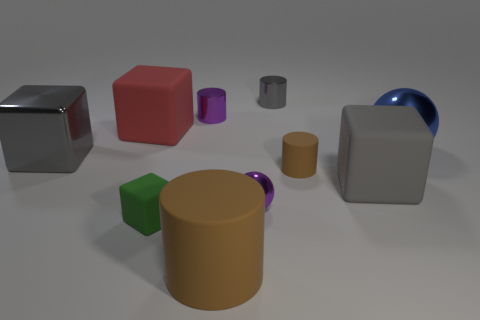Subtract all metallic cubes. How many cubes are left? 3 Subtract all green blocks. How many blocks are left? 3 Subtract 1 spheres. How many spheres are left? 1 Subtract all cubes. How many objects are left? 6 Add 1 rubber cylinders. How many rubber cylinders are left? 3 Add 2 large metallic spheres. How many large metallic spheres exist? 3 Subtract 1 gray cubes. How many objects are left? 9 Subtract all green cylinders. Subtract all green balls. How many cylinders are left? 4 Subtract all green cylinders. How many gray spheres are left? 0 Subtract all cyan cubes. Subtract all small metal spheres. How many objects are left? 9 